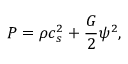Convert formula to latex. <formula><loc_0><loc_0><loc_500><loc_500>P = \rho c _ { s } ^ { 2 } + \frac { G } { 2 } \psi ^ { 2 } ,</formula> 